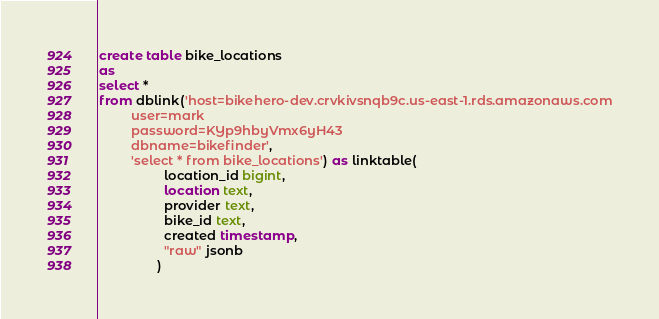<code> <loc_0><loc_0><loc_500><loc_500><_SQL_>create table bike_locations
as
select *
from dblink('host=bikehero-dev.crvkivsnqb9c.us-east-1.rds.amazonaws.com
	     user=mark
	     password=KYp9hbyVmx6yH43
	     dbname=bikefinder',
	     'select * from bike_locations') as linktable(
				  location_id bigint,
				  location text,
				  provider text,
				  bike_id text,
				  created timestamp,
				  "raw" jsonb
				)</code> 